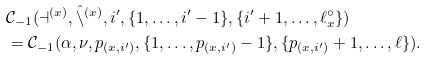<formula> <loc_0><loc_0><loc_500><loc_500>& \mathcal { C } _ { - 1 } ( \mathcal { a } ^ { ( x ) } , \hat { \mathcal { n } } ^ { ( x ) } , i ^ { \prime } , \{ 1 , \dots , i ^ { \prime } - 1 \} , \{ i ^ { \prime } + 1 , \dots , \ell ^ { \circ } _ { x } \} ) \\ & = \mathcal { C } _ { - 1 } ( \alpha , \nu , p _ { ( x , i ^ { \prime } ) } , \{ 1 , \dots , p _ { ( x , i ^ { \prime } ) } - 1 \} , \{ p _ { ( x , i ^ { \prime } ) } + 1 , \dots , \ell \} ) .</formula> 